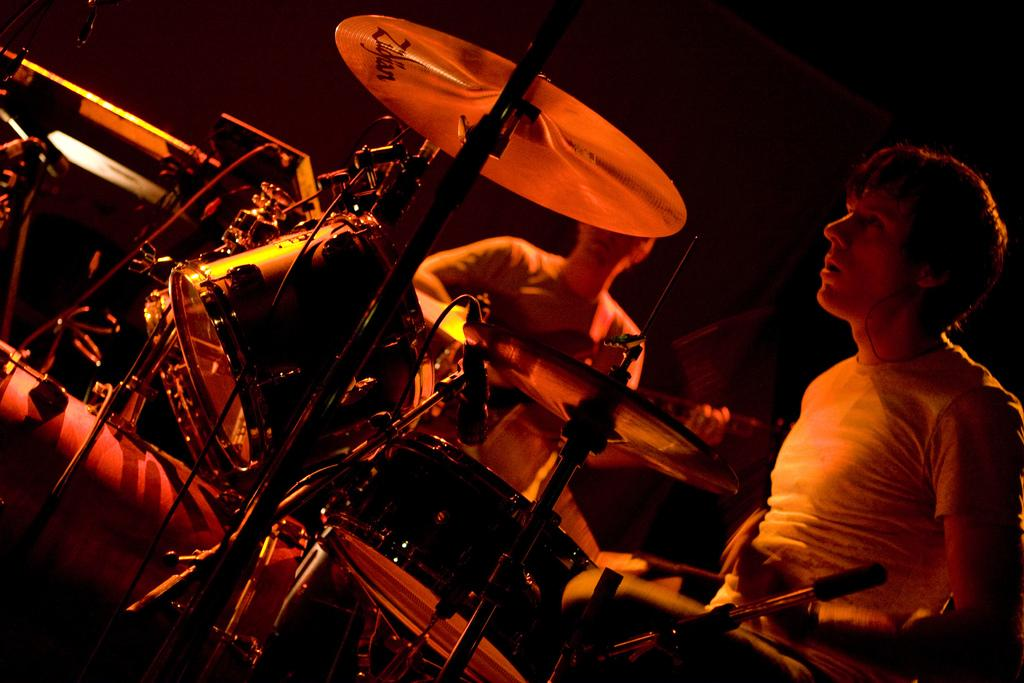What type of musical instruments can be seen in the image? There are musical instruments in the image, including drums and a guitar. What is the person on the left side of the image doing? The person on the left side of the image is playing drums. What is the person on the right side of the image doing? The person on the right side of the image is playing guitar. What device might be used for amplifying the sound of the instruments in the image? There is a microphone in the image, which could be used for amplifying the sound of the instruments. What is the color of the background in the image? The background of the image is dark. What type of insurance policy is the person playing drums discussing with their parent in the image? There is no mention of insurance or parents in the image; it features people playing musical instruments and a microphone. 